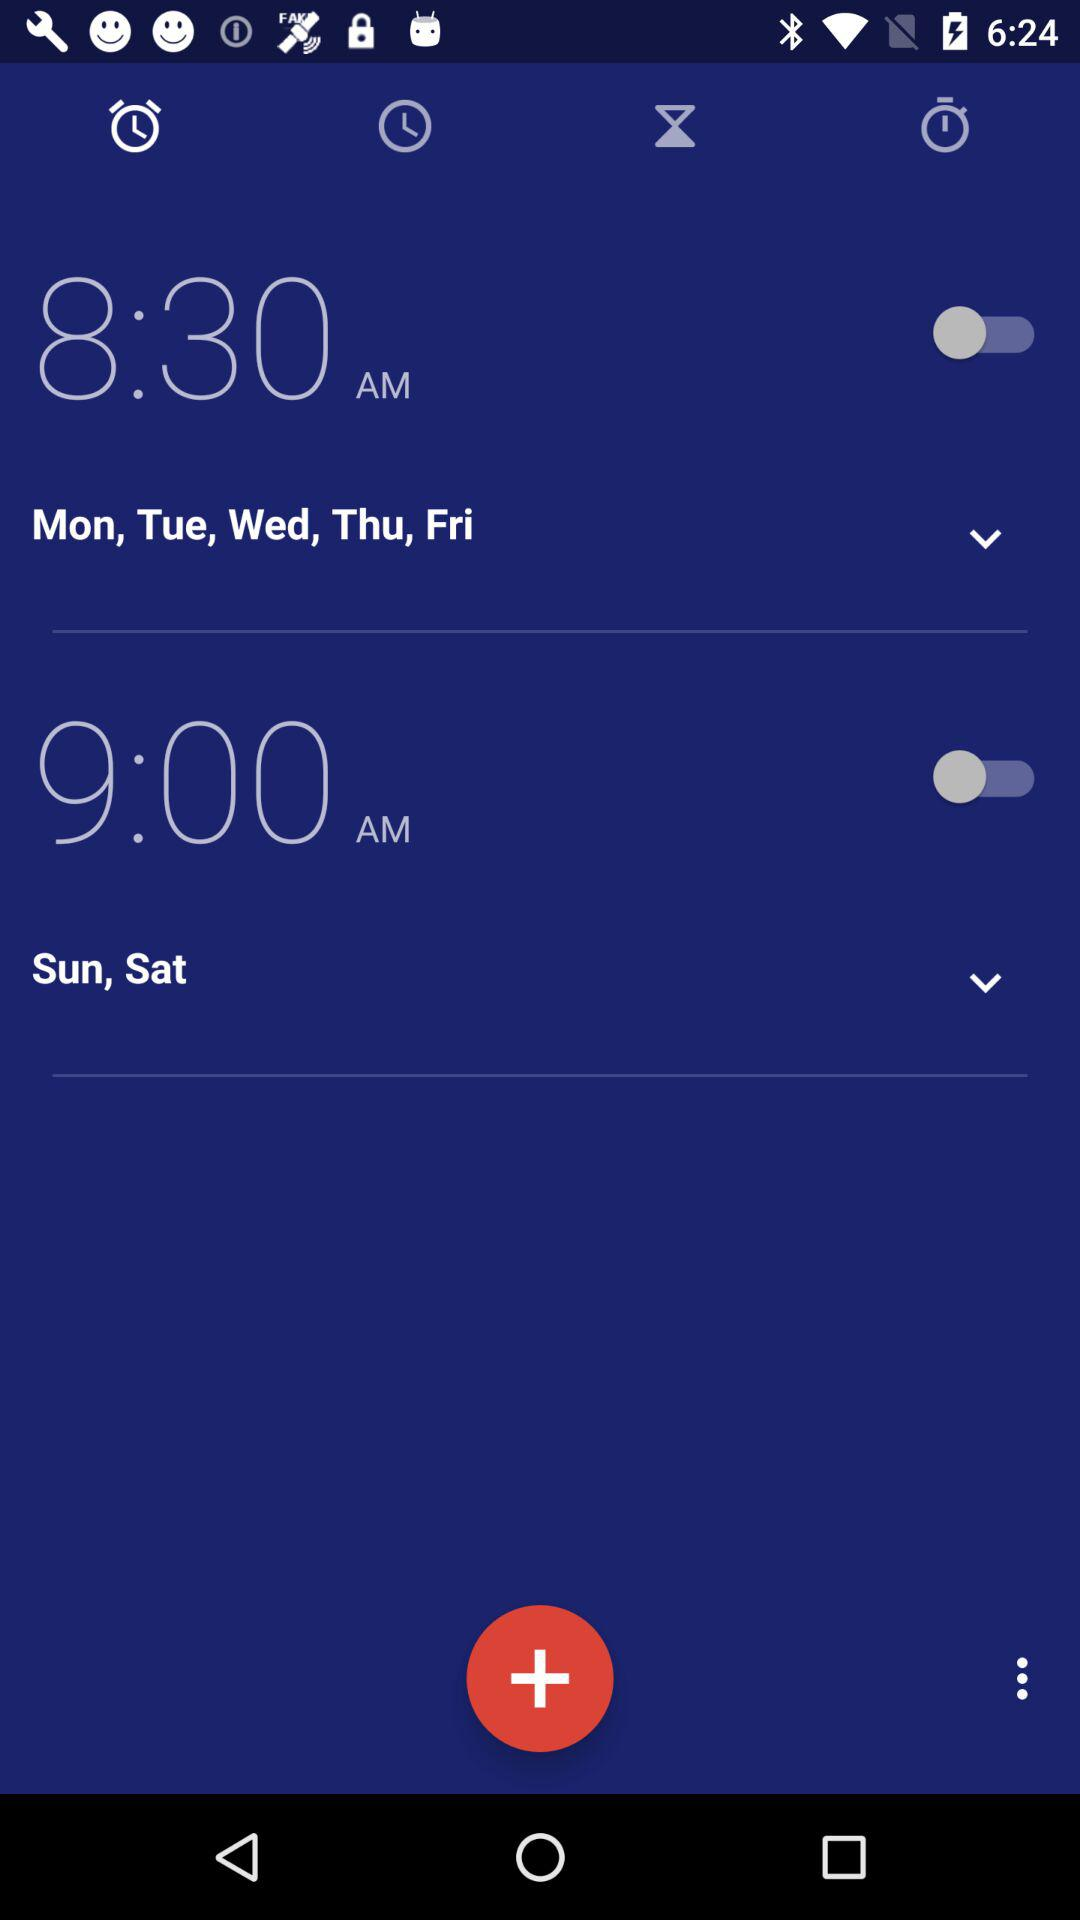For what time is the alarm set for Sunday and Saturday? The alarm is set for 9:00 AM. 